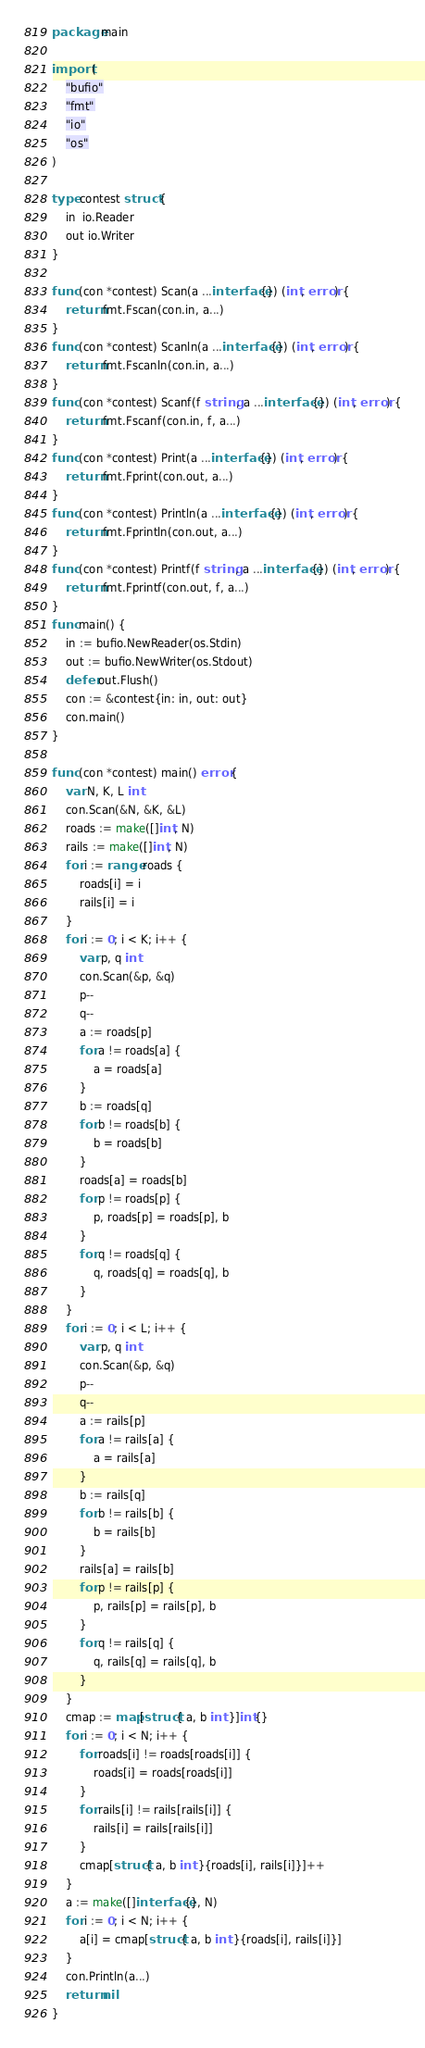Convert code to text. <code><loc_0><loc_0><loc_500><loc_500><_Go_>package main

import (
	"bufio"
	"fmt"
	"io"
	"os"
)

type contest struct {
	in  io.Reader
	out io.Writer
}

func (con *contest) Scan(a ...interface{}) (int, error) {
	return fmt.Fscan(con.in, a...)
}
func (con *contest) Scanln(a ...interface{}) (int, error) {
	return fmt.Fscanln(con.in, a...)
}
func (con *contest) Scanf(f string, a ...interface{}) (int, error) {
	return fmt.Fscanf(con.in, f, a...)
}
func (con *contest) Print(a ...interface{}) (int, error) {
	return fmt.Fprint(con.out, a...)
}
func (con *contest) Println(a ...interface{}) (int, error) {
	return fmt.Fprintln(con.out, a...)
}
func (con *contest) Printf(f string, a ...interface{}) (int, error) {
	return fmt.Fprintf(con.out, f, a...)
}
func main() {
	in := bufio.NewReader(os.Stdin)
	out := bufio.NewWriter(os.Stdout)
	defer out.Flush()
	con := &contest{in: in, out: out}
	con.main()
}

func (con *contest) main() error {
	var N, K, L int
	con.Scan(&N, &K, &L)
	roads := make([]int, N)
	rails := make([]int, N)
	for i := range roads {
		roads[i] = i
		rails[i] = i
	}
	for i := 0; i < K; i++ {
		var p, q int
		con.Scan(&p, &q)
		p--
		q--
		a := roads[p]
		for a != roads[a] {
			a = roads[a]
		}
		b := roads[q]
		for b != roads[b] {
			b = roads[b]
		}
		roads[a] = roads[b]
		for p != roads[p] {
			p, roads[p] = roads[p], b
		}
		for q != roads[q] {
			q, roads[q] = roads[q], b
		}
	}
	for i := 0; i < L; i++ {
		var p, q int
		con.Scan(&p, &q)
		p--
		q--
		a := rails[p]
		for a != rails[a] {
			a = rails[a]
		}
		b := rails[q]
		for b != rails[b] {
			b = rails[b]
		}
		rails[a] = rails[b]
		for p != rails[p] {
			p, rails[p] = rails[p], b
		}
		for q != rails[q] {
			q, rails[q] = rails[q], b
		}
	}
	cmap := map[struct{ a, b int }]int{}
	for i := 0; i < N; i++ {
		for roads[i] != roads[roads[i]] {
			roads[i] = roads[roads[i]]
		}
		for rails[i] != rails[rails[i]] {
			rails[i] = rails[rails[i]]
		}
		cmap[struct{ a, b int }{roads[i], rails[i]}]++
	}
	a := make([]interface{}, N)
	for i := 0; i < N; i++ {
		a[i] = cmap[struct{ a, b int }{roads[i], rails[i]}]
	}
	con.Println(a...)
	return nil
}
</code> 